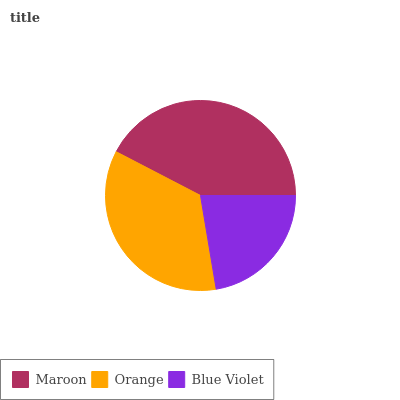Is Blue Violet the minimum?
Answer yes or no. Yes. Is Maroon the maximum?
Answer yes or no. Yes. Is Orange the minimum?
Answer yes or no. No. Is Orange the maximum?
Answer yes or no. No. Is Maroon greater than Orange?
Answer yes or no. Yes. Is Orange less than Maroon?
Answer yes or no. Yes. Is Orange greater than Maroon?
Answer yes or no. No. Is Maroon less than Orange?
Answer yes or no. No. Is Orange the high median?
Answer yes or no. Yes. Is Orange the low median?
Answer yes or no. Yes. Is Blue Violet the high median?
Answer yes or no. No. Is Maroon the low median?
Answer yes or no. No. 